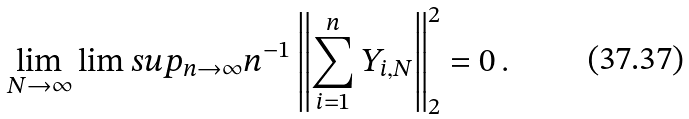Convert formula to latex. <formula><loc_0><loc_0><loc_500><loc_500>\lim _ { N \rightarrow \infty } \lim s u p _ { n \rightarrow \infty } n ^ { - 1 } \left \| \sum _ { i = 1 } ^ { n } Y _ { i , N } \right \| ^ { 2 } _ { 2 } = 0 \, .</formula> 